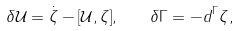Convert formula to latex. <formula><loc_0><loc_0><loc_500><loc_500>\delta \mathcal { U } = \dot { \zeta } - [ \mathcal { U } , \zeta ] , \quad \delta \Gamma = - d ^ { \Gamma } \zeta ,</formula> 